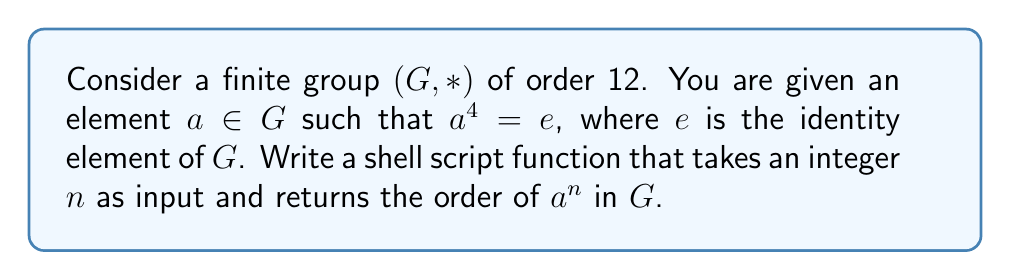Teach me how to tackle this problem. To solve this problem, let's break it down into steps:

1. First, recall that the order of an element $x$ in a group is the smallest positive integer $k$ such that $x^k = e$.

2. We are given that $a^4 = e$, which means the order of $a$ is a divisor of 4. The possible orders for $a$ are 1, 2, or 4.

3. To find the order of $a^n$, we need to find the smallest positive integer $k$ such that $(a^n)^k = e$.

4. We can use the property that $(a^n)^k = a^{nk}$.

5. So, we need to find the smallest positive integer $k$ such that $a^{nk} = e$.

6. Since we know that $a^4 = e$, this is equivalent to finding the smallest positive integer $k$ such that $nk$ is divisible by 4.

7. In mathematical terms, we're looking for $k = \frac{4}{\gcd(n, 4)}$.

Now, let's implement this as a shell script function:

```bash
order_of_an() {
    n=$1
    gcd=$(( n > 4 ? 4 : n ))
    while (( n % gcd != 0 )); do
        gcd=$(( gcd - 1 ))
    done
    echo $(( 4 / gcd ))
}
```

This function does the following:
- Takes $n$ as an input parameter
- Calculates the GCD of $n$ and 4 using a simple loop
- Returns $\frac{4}{\gcd(n, 4)}$

To use this function, you would call it with an integer argument, like:

```bash
order_of_an 3
```

This would return the order of $a^3$ in the group.
Answer: The order of $a^n$ in $G$ is given by the formula:

$$ \text{order}(a^n) = \frac{4}{\gcd(n, 4)} $$

The shell script function implementing this solution is:

```bash
order_of_an() {
    n=$1
    gcd=$(( n > 4 ? 4 : n ))
    while (( n % gcd != 0 )); do
        gcd=$(( gcd - 1 ))
    done
    echo $(( 4 / gcd ))
}
``` 